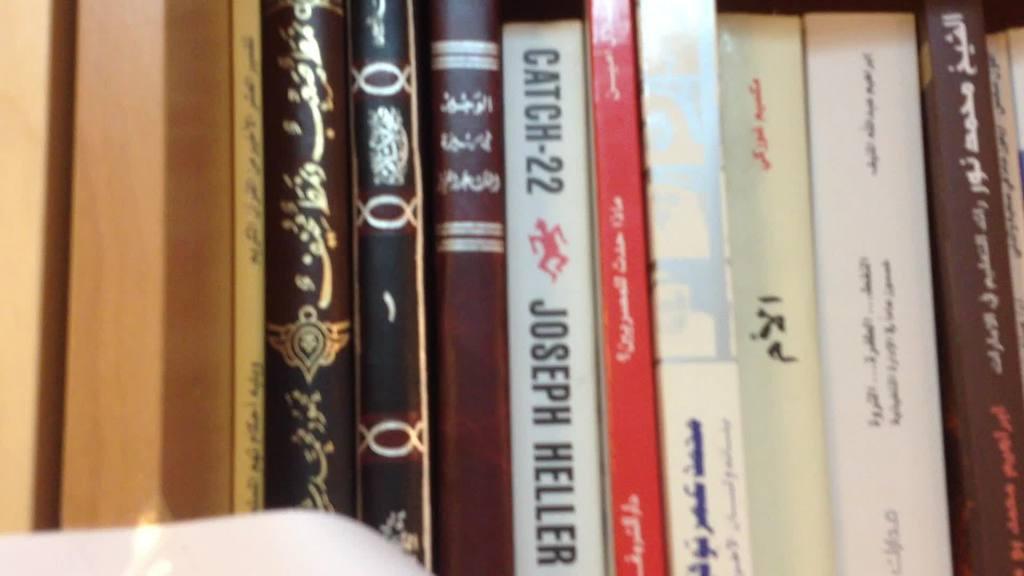Who authored catch 22?
Your answer should be very brief. Joseph heller. 